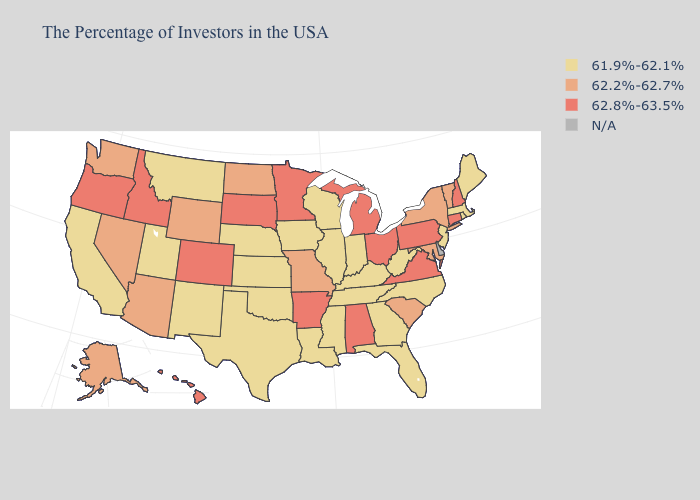What is the lowest value in the West?
Short answer required. 61.9%-62.1%. What is the value of Ohio?
Concise answer only. 62.8%-63.5%. Does Maryland have the lowest value in the USA?
Keep it brief. No. Which states have the lowest value in the West?
Give a very brief answer. New Mexico, Utah, Montana, California. How many symbols are there in the legend?
Give a very brief answer. 4. What is the value of Wyoming?
Quick response, please. 62.2%-62.7%. What is the highest value in the USA?
Concise answer only. 62.8%-63.5%. What is the value of Virginia?
Short answer required. 62.8%-63.5%. Name the states that have a value in the range 62.8%-63.5%?
Answer briefly. New Hampshire, Connecticut, Pennsylvania, Virginia, Ohio, Michigan, Alabama, Arkansas, Minnesota, South Dakota, Colorado, Idaho, Oregon, Hawaii. Does California have the highest value in the USA?
Concise answer only. No. What is the highest value in the USA?
Short answer required. 62.8%-63.5%. What is the value of New Mexico?
Keep it brief. 61.9%-62.1%. Name the states that have a value in the range 62.2%-62.7%?
Answer briefly. Vermont, New York, Maryland, South Carolina, Missouri, North Dakota, Wyoming, Arizona, Nevada, Washington, Alaska. What is the lowest value in states that border Washington?
Keep it brief. 62.8%-63.5%. Which states hav the highest value in the South?
Give a very brief answer. Virginia, Alabama, Arkansas. 